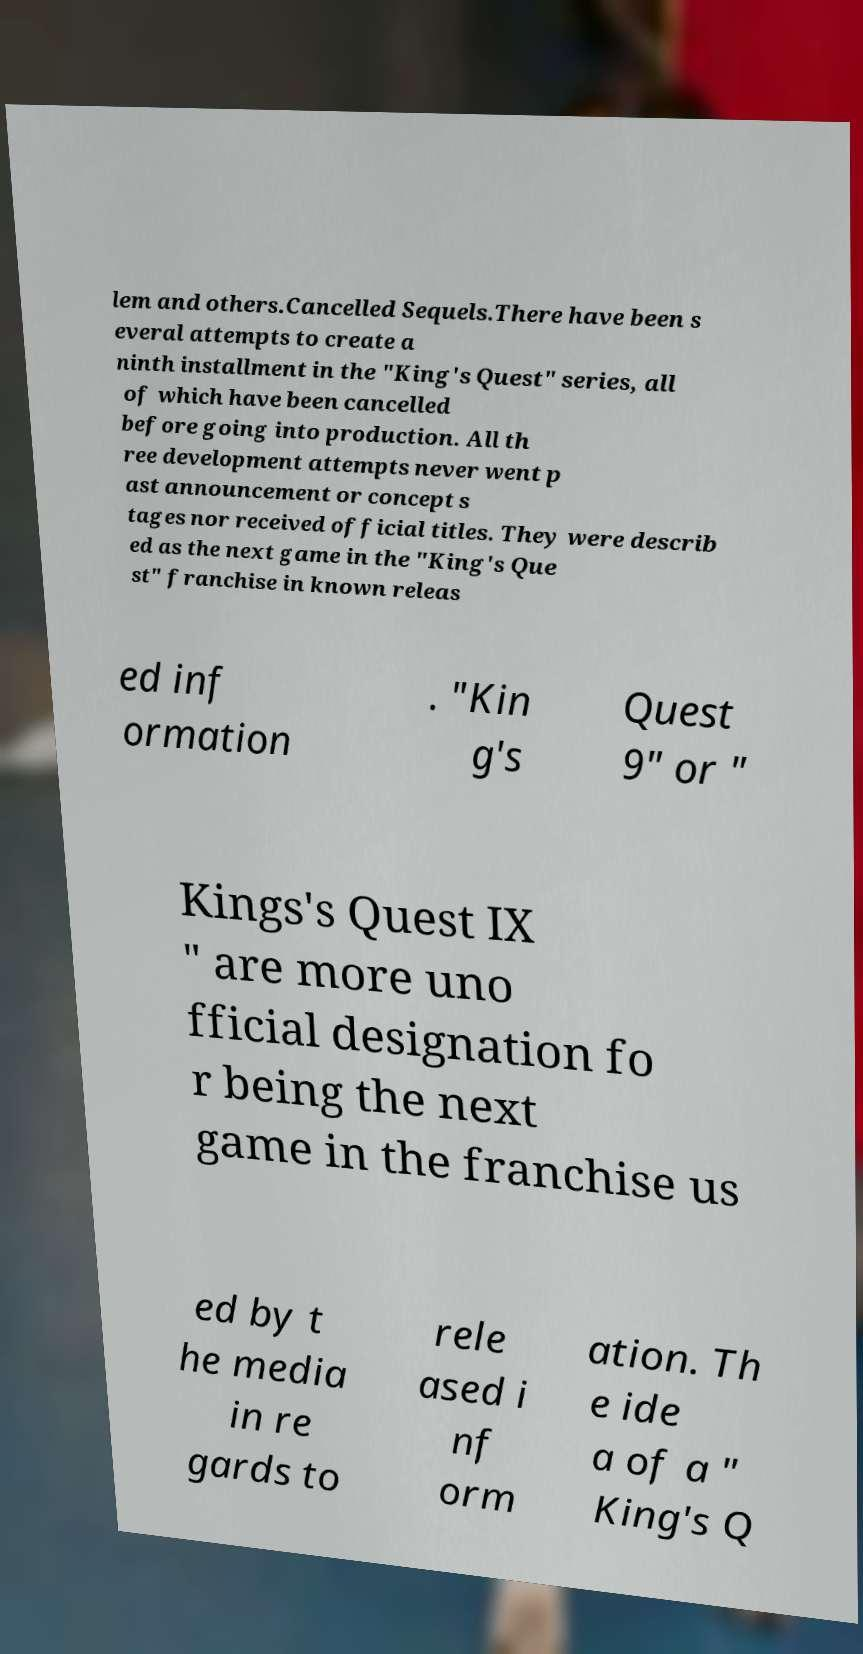I need the written content from this picture converted into text. Can you do that? lem and others.Cancelled Sequels.There have been s everal attempts to create a ninth installment in the "King's Quest" series, all of which have been cancelled before going into production. All th ree development attempts never went p ast announcement or concept s tages nor received official titles. They were describ ed as the next game in the "King's Que st" franchise in known releas ed inf ormation . "Kin g's Quest 9" or " Kings's Quest IX " are more uno fficial designation fo r being the next game in the franchise us ed by t he media in re gards to rele ased i nf orm ation. Th e ide a of a " King's Q 